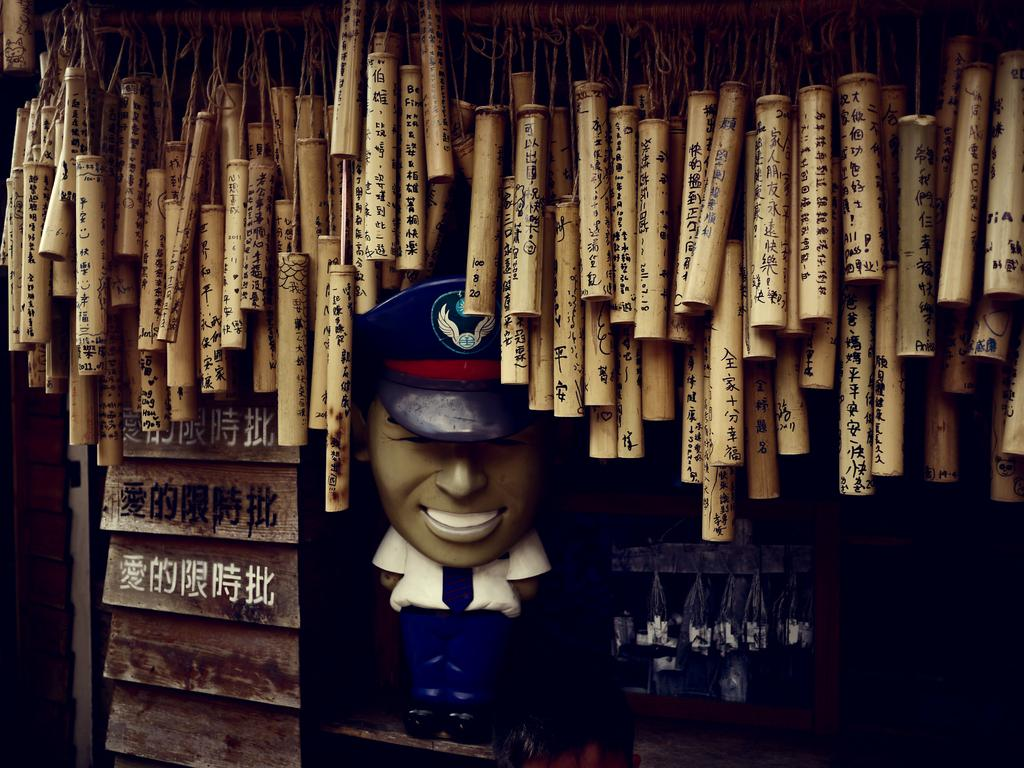Provide a one-sentence caption for the provided image. A group of bamboo tubes in asian caligraphy with the one closest to a statue of a postman having the numbers 100, 8 and 20. 